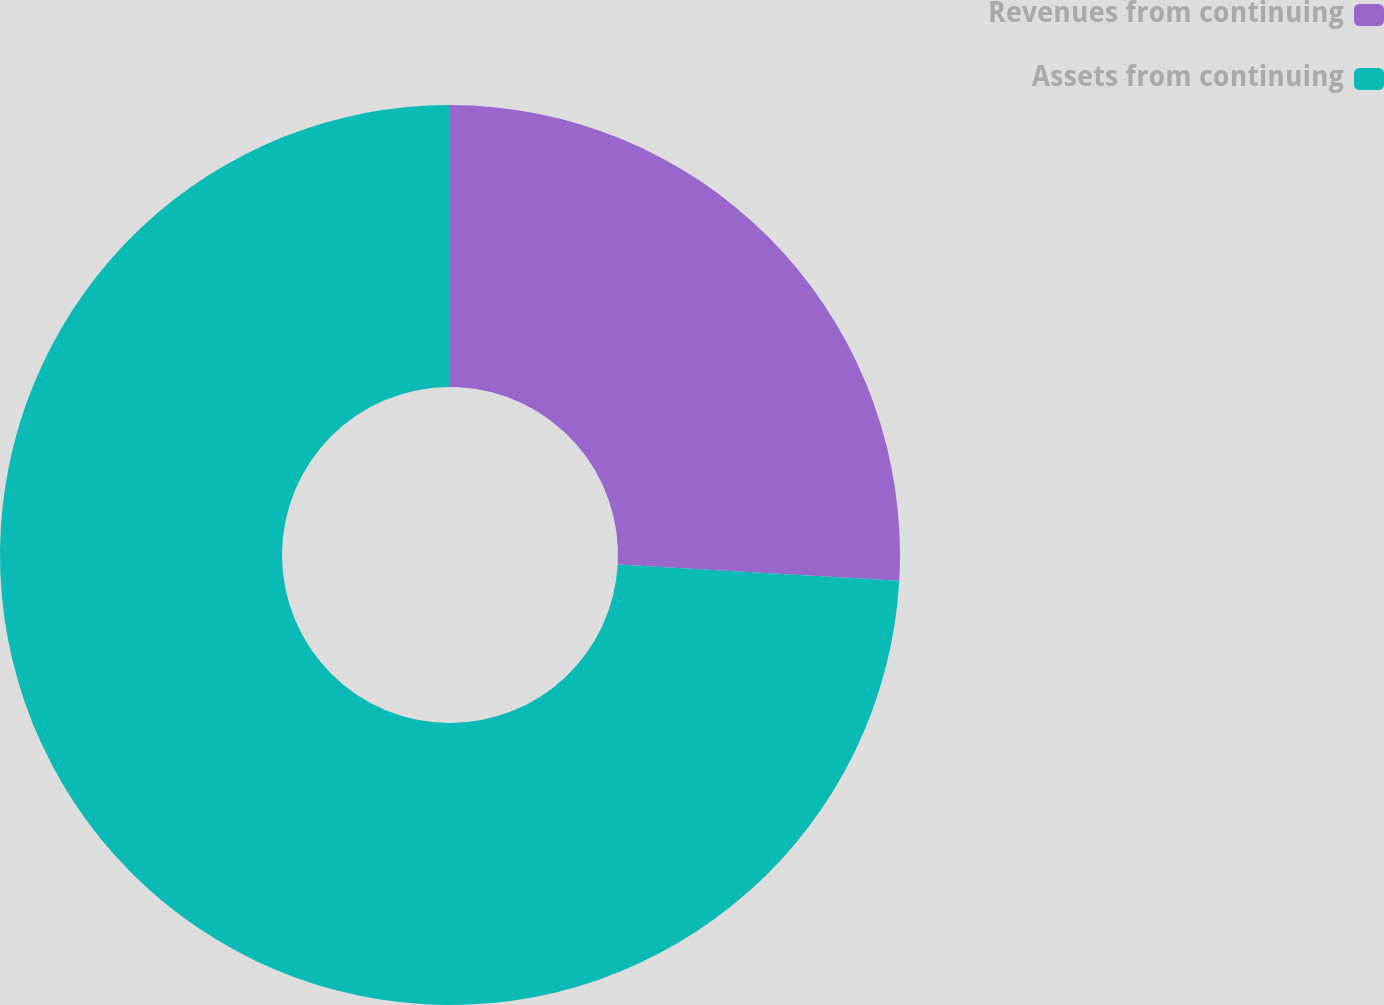<chart> <loc_0><loc_0><loc_500><loc_500><pie_chart><fcel>Revenues from continuing<fcel>Assets from continuing<nl><fcel>25.91%<fcel>74.09%<nl></chart> 